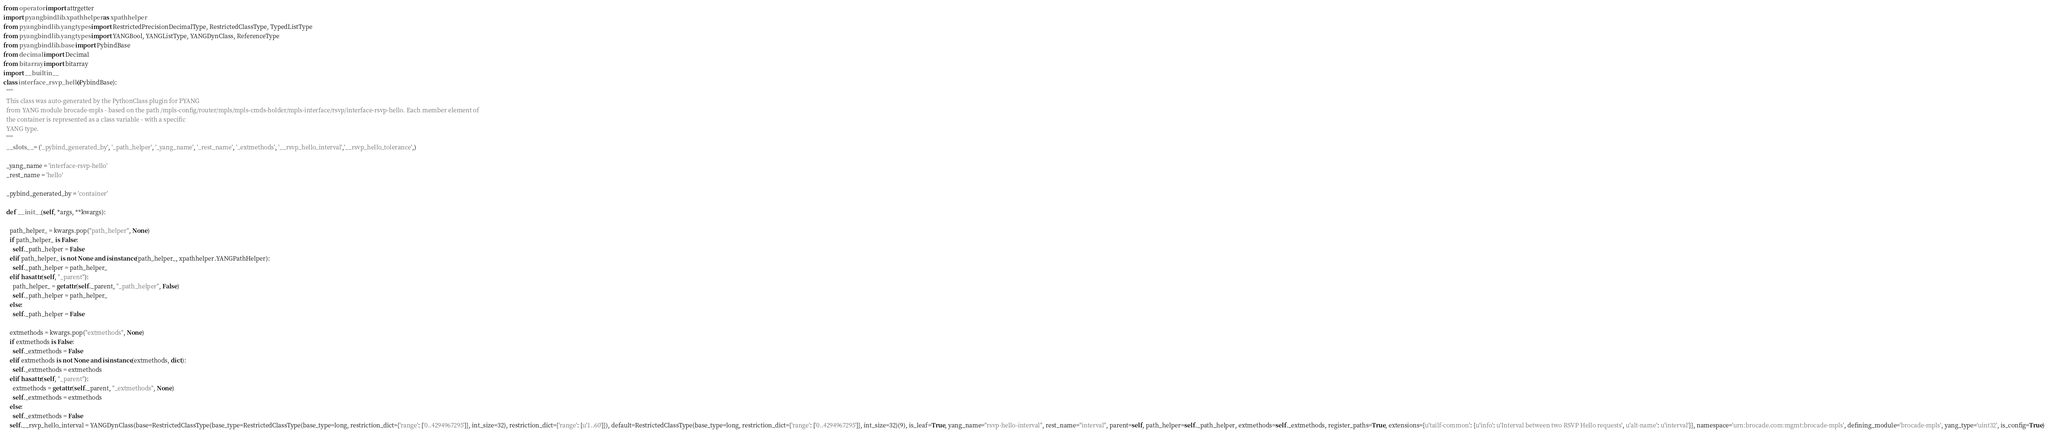Convert code to text. <code><loc_0><loc_0><loc_500><loc_500><_Python_>
from operator import attrgetter
import pyangbind.lib.xpathhelper as xpathhelper
from pyangbind.lib.yangtypes import RestrictedPrecisionDecimalType, RestrictedClassType, TypedListType
from pyangbind.lib.yangtypes import YANGBool, YANGListType, YANGDynClass, ReferenceType
from pyangbind.lib.base import PybindBase
from decimal import Decimal
from bitarray import bitarray
import __builtin__
class interface_rsvp_hello(PybindBase):
  """
  This class was auto-generated by the PythonClass plugin for PYANG
  from YANG module brocade-mpls - based on the path /mpls-config/router/mpls/mpls-cmds-holder/mpls-interface/rsvp/interface-rsvp-hello. Each member element of
  the container is represented as a class variable - with a specific
  YANG type.
  """
  __slots__ = ('_pybind_generated_by', '_path_helper', '_yang_name', '_rest_name', '_extmethods', '__rsvp_hello_interval','__rsvp_hello_tolerance',)

  _yang_name = 'interface-rsvp-hello'
  _rest_name = 'hello'

  _pybind_generated_by = 'container'

  def __init__(self, *args, **kwargs):

    path_helper_ = kwargs.pop("path_helper", None)
    if path_helper_ is False:
      self._path_helper = False
    elif path_helper_ is not None and isinstance(path_helper_, xpathhelper.YANGPathHelper):
      self._path_helper = path_helper_
    elif hasattr(self, "_parent"):
      path_helper_ = getattr(self._parent, "_path_helper", False)
      self._path_helper = path_helper_
    else:
      self._path_helper = False

    extmethods = kwargs.pop("extmethods", None)
    if extmethods is False:
      self._extmethods = False
    elif extmethods is not None and isinstance(extmethods, dict):
      self._extmethods = extmethods
    elif hasattr(self, "_parent"):
      extmethods = getattr(self._parent, "_extmethods", None)
      self._extmethods = extmethods
    else:
      self._extmethods = False
    self.__rsvp_hello_interval = YANGDynClass(base=RestrictedClassType(base_type=RestrictedClassType(base_type=long, restriction_dict={'range': ['0..4294967295']}, int_size=32), restriction_dict={'range': [u'1..60']}), default=RestrictedClassType(base_type=long, restriction_dict={'range': ['0..4294967295']}, int_size=32)(9), is_leaf=True, yang_name="rsvp-hello-interval", rest_name="interval", parent=self, path_helper=self._path_helper, extmethods=self._extmethods, register_paths=True, extensions={u'tailf-common': {u'info': u'Interval between two RSVP Hello requests', u'alt-name': u'interval'}}, namespace='urn:brocade.com:mgmt:brocade-mpls', defining_module='brocade-mpls', yang_type='uint32', is_config=True)</code> 